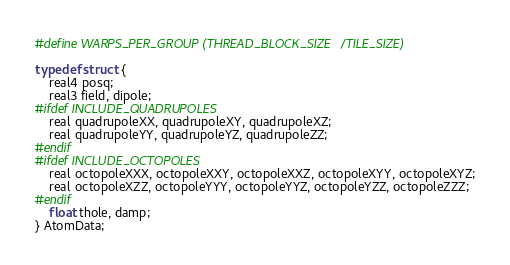Convert code to text. <code><loc_0><loc_0><loc_500><loc_500><_Cuda_>#define WARPS_PER_GROUP (THREAD_BLOCK_SIZE/TILE_SIZE)

typedef struct {
    real4 posq;
    real3 field, dipole;
#ifdef INCLUDE_QUADRUPOLES
    real quadrupoleXX, quadrupoleXY, quadrupoleXZ;
    real quadrupoleYY, quadrupoleYZ, quadrupoleZZ;
#endif
#ifdef INCLUDE_OCTOPOLES
    real octopoleXXX, octopoleXXY, octopoleXXZ, octopoleXYY, octopoleXYZ;
    real octopoleXZZ, octopoleYYY, octopoleYYZ, octopoleYZZ, octopoleZZZ;
#endif
    float thole, damp;
} AtomData;
</code> 